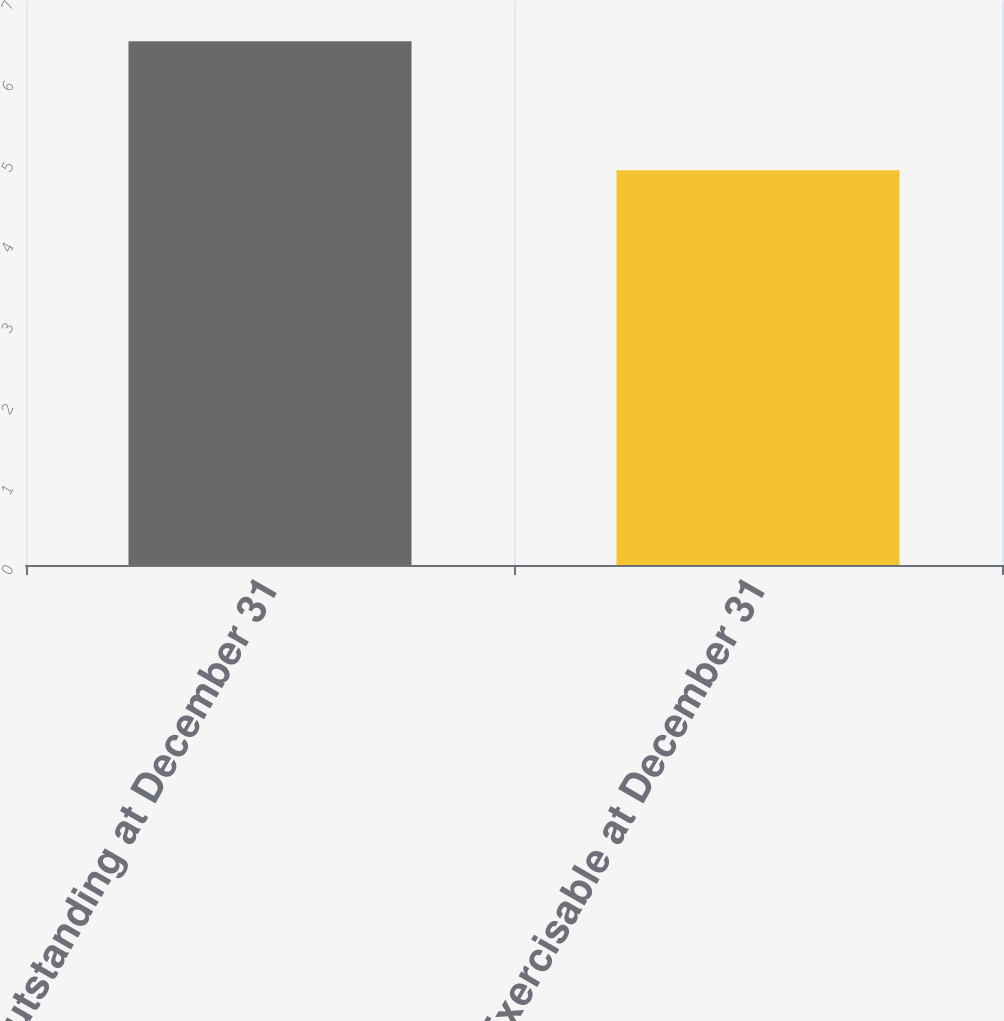Convert chart. <chart><loc_0><loc_0><loc_500><loc_500><bar_chart><fcel>Outstanding at December 31<fcel>Exercisable at December 31<nl><fcel>6.5<fcel>4.9<nl></chart> 